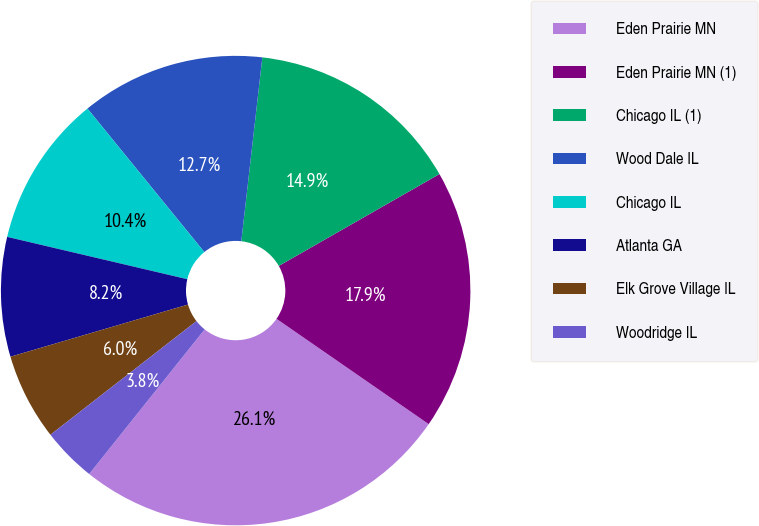Convert chart to OTSL. <chart><loc_0><loc_0><loc_500><loc_500><pie_chart><fcel>Eden Prairie MN<fcel>Eden Prairie MN (1)<fcel>Chicago IL (1)<fcel>Wood Dale IL<fcel>Chicago IL<fcel>Atlanta GA<fcel>Elk Grove Village IL<fcel>Woodridge IL<nl><fcel>26.09%<fcel>17.9%<fcel>14.92%<fcel>12.69%<fcel>10.45%<fcel>8.22%<fcel>5.98%<fcel>3.75%<nl></chart> 